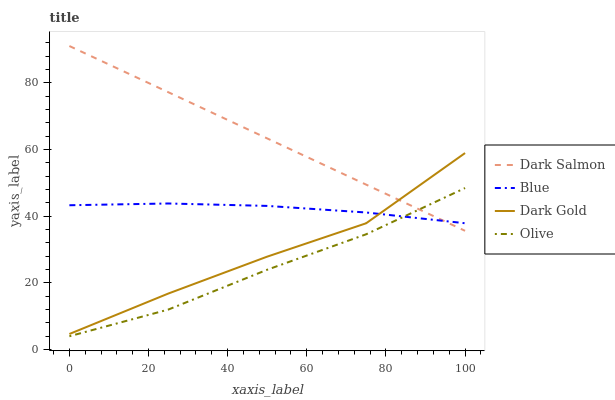Does Olive have the minimum area under the curve?
Answer yes or no. Yes. Does Dark Salmon have the maximum area under the curve?
Answer yes or no. Yes. Does Dark Salmon have the minimum area under the curve?
Answer yes or no. No. Does Olive have the maximum area under the curve?
Answer yes or no. No. Is Dark Salmon the smoothest?
Answer yes or no. Yes. Is Dark Gold the roughest?
Answer yes or no. Yes. Is Olive the smoothest?
Answer yes or no. No. Is Olive the roughest?
Answer yes or no. No. Does Olive have the lowest value?
Answer yes or no. Yes. Does Dark Salmon have the lowest value?
Answer yes or no. No. Does Dark Salmon have the highest value?
Answer yes or no. Yes. Does Olive have the highest value?
Answer yes or no. No. Is Olive less than Dark Gold?
Answer yes or no. Yes. Is Dark Gold greater than Olive?
Answer yes or no. Yes. Does Blue intersect Dark Gold?
Answer yes or no. Yes. Is Blue less than Dark Gold?
Answer yes or no. No. Is Blue greater than Dark Gold?
Answer yes or no. No. Does Olive intersect Dark Gold?
Answer yes or no. No. 